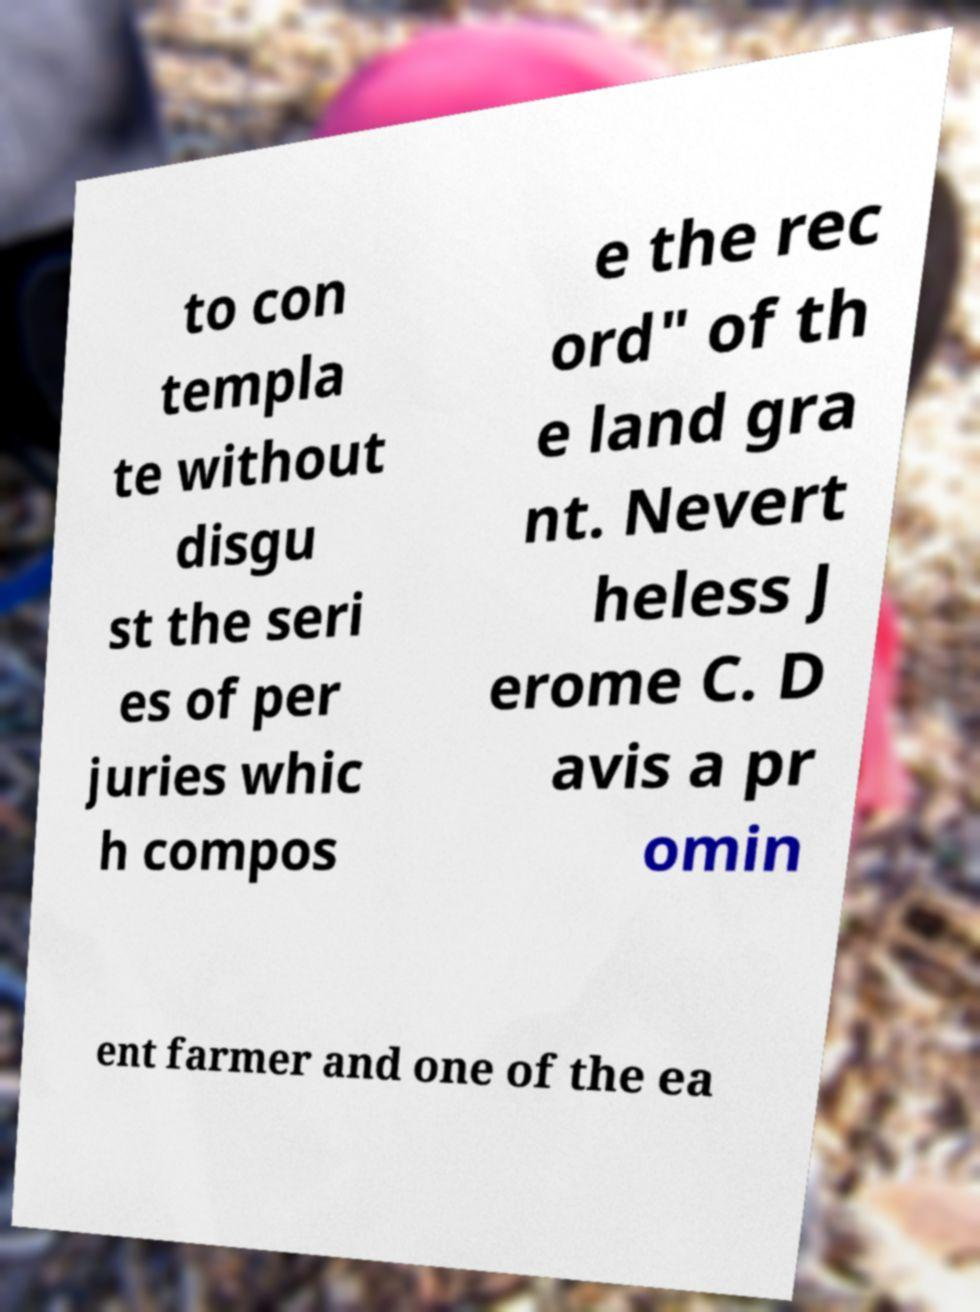There's text embedded in this image that I need extracted. Can you transcribe it verbatim? to con templa te without disgu st the seri es of per juries whic h compos e the rec ord" of th e land gra nt. Nevert heless J erome C. D avis a pr omin ent farmer and one of the ea 